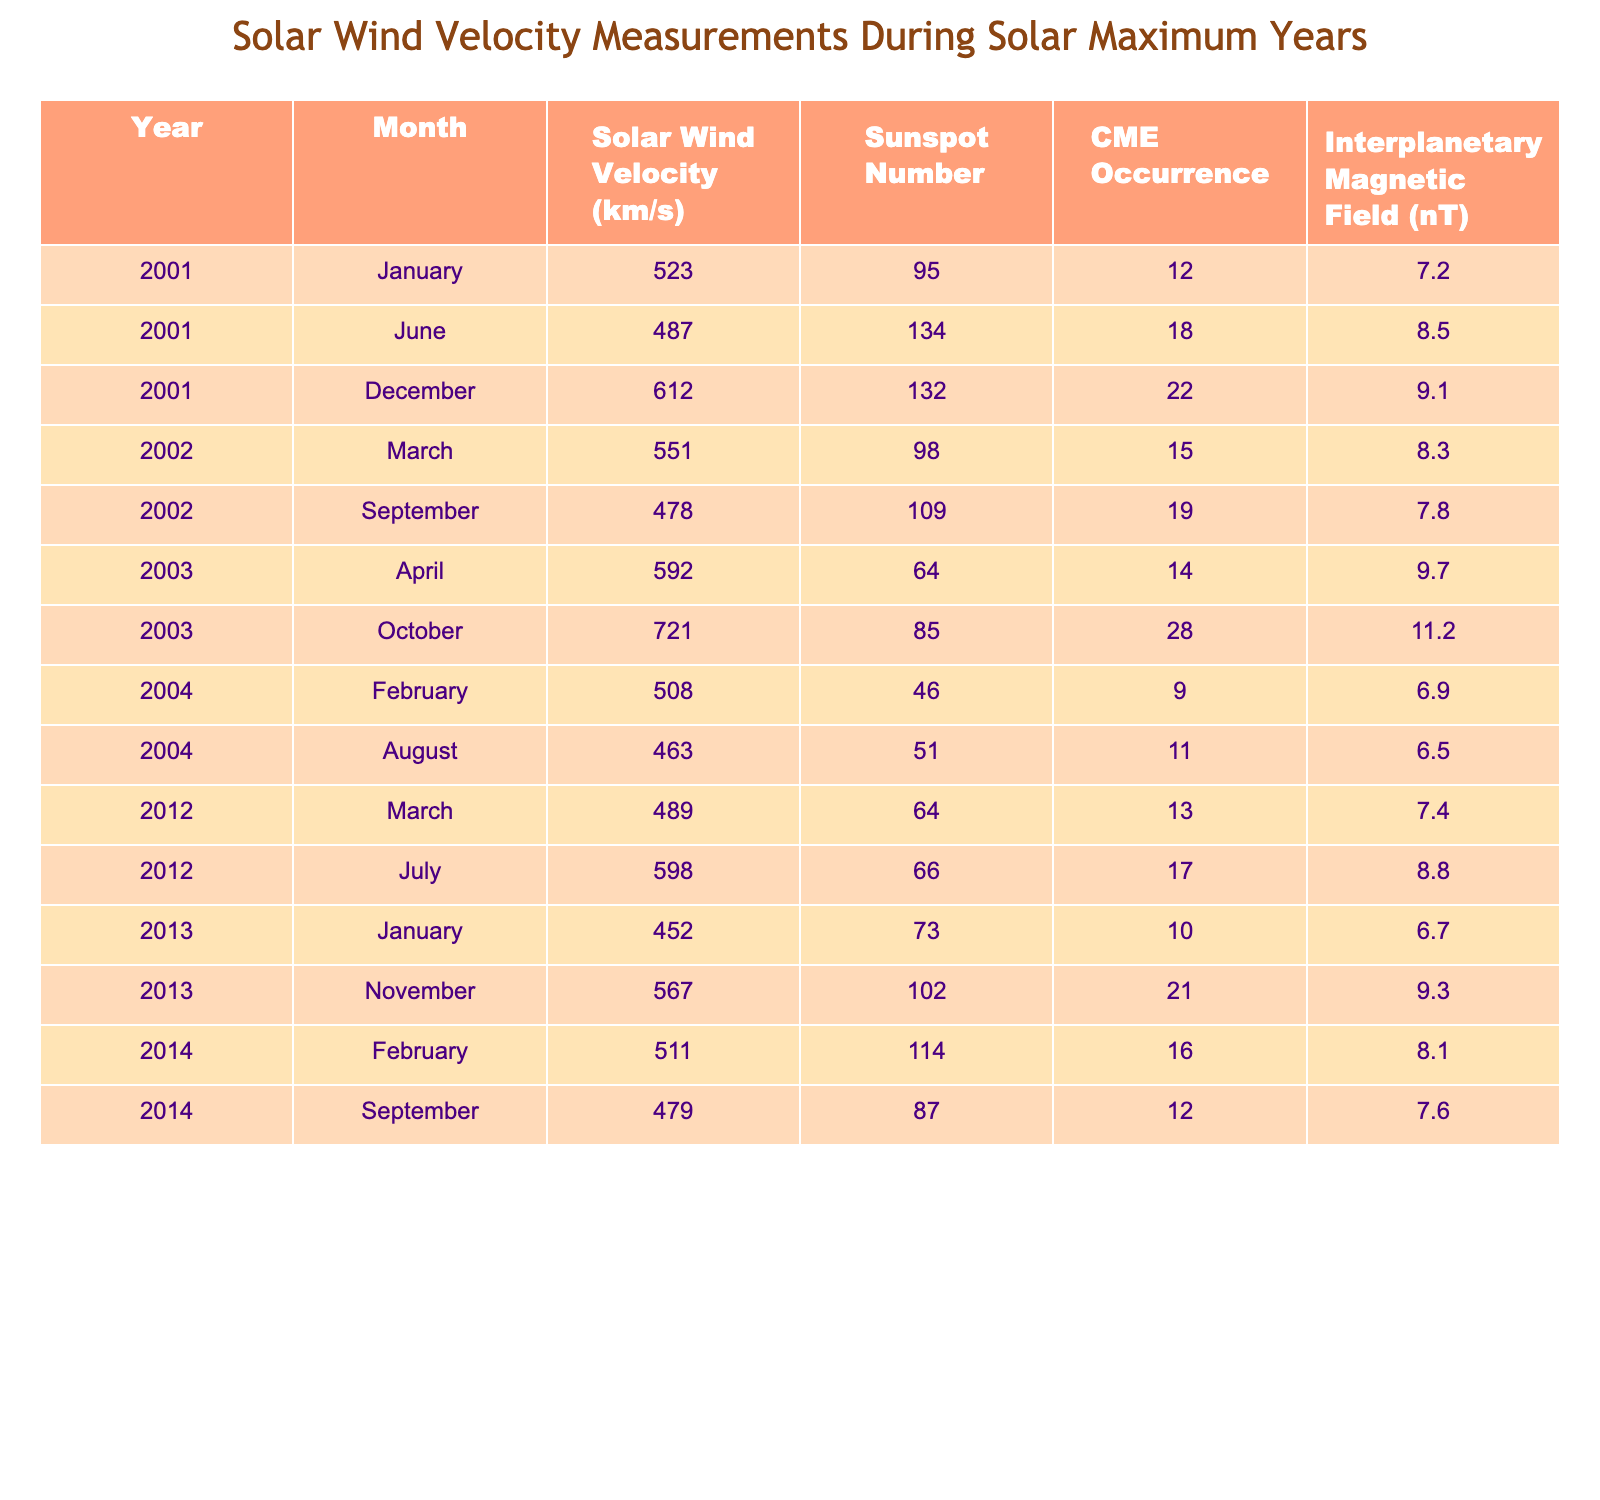What is the solar wind velocity recorded in December 2001? The table shows the solar wind velocity for December 2001 listed as 612 km/s.
Answer: 612 km/s Which month in 2003 had the highest solar wind velocity? In the table, the solar wind velocities for 2003 are 592 km/s in April and 721 km/s in October. October has the highest value.
Answer: October How many times were CMEs observed in July 2012? The table indicates that the number of CME occurrences in July 2012 was 17.
Answer: 17 What is the average solar wind velocity for the year 2014? The table shows solar wind velocities for 2014 as 511 km/s in February and 479 km/s in September. The average is (511 + 479) / 2 = 495 km/s.
Answer: 495 km/s Was the sunspot number higher in January 2013 than in June 2001? The sunspot number in January 2013 is 73, and in June 2001 it is 134. Since 134 is greater than 73, the statement is false.
Answer: No What is the difference in solar wind velocity between the highest and lowest recorded values in 2002? In 2002, the highest value is 551 km/s in March, and the lowest is 478 km/s in September. The difference is 551 - 478 = 73 km/s.
Answer: 73 km/s In which year was the solar wind velocity measurement below 500 km/s recorded twice? By examining the table, the year 2001 has two recorded measurements below 500 km/s (January and June).
Answer: 2001 Was the interplanetary magnetic field stronger in March 2012 compared to September 2014? In March 2012, the interplanetary magnetic field was 7.4 nT, while in September 2014 it was 7.6 nT. Since 7.6 nT is greater, the statement is false.
Answer: No What is the total number of CME occurrences during the year 2001? The table shows CME occurrences for 2001 as 12, 18, and 22 for January, June, and December respectively. The total is 12 + 18 + 22 = 52.
Answer: 52 Identify the month with the lowest interplanetary magnetic field measurement. The table shows interplanetary magnetic field measurements, where February 2004 has the lowest value of 6.9 nT.
Answer: February 2004 